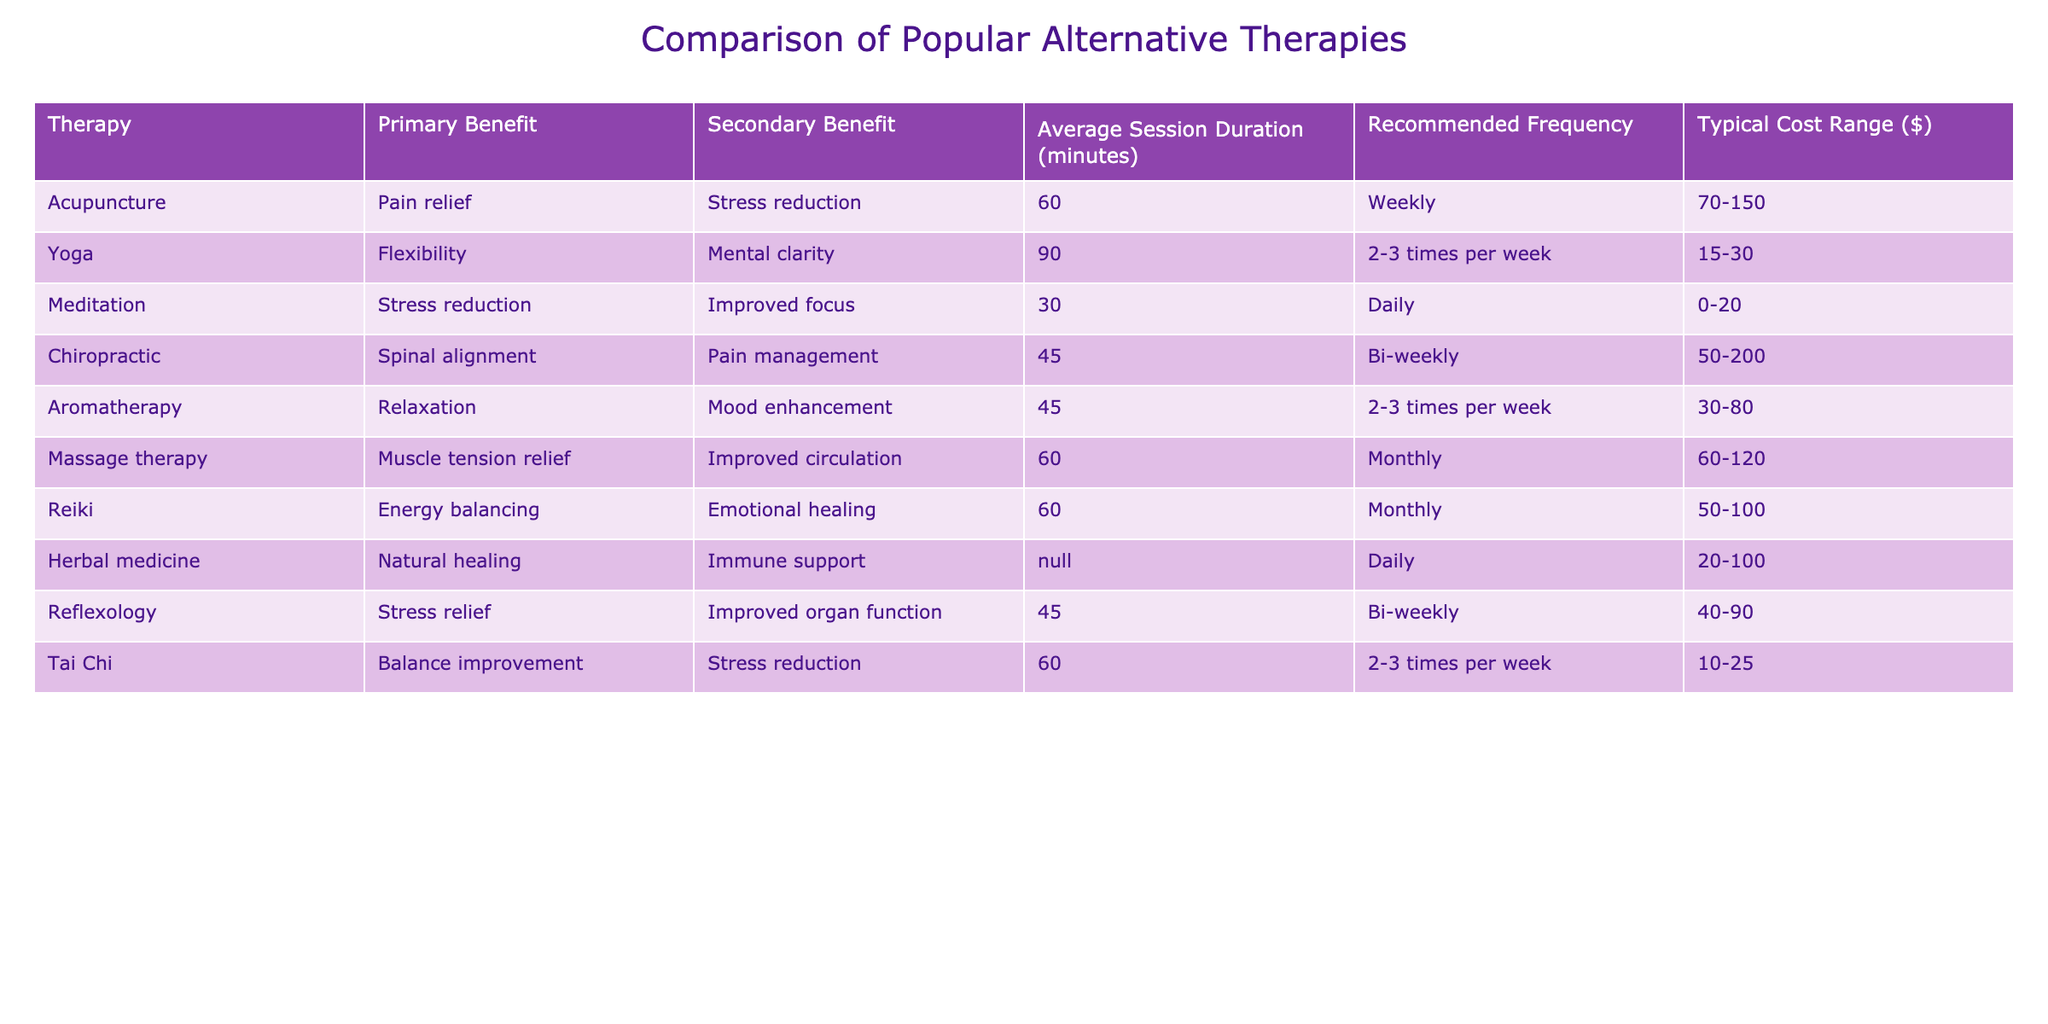What is the primary benefit of Reiki? According to the table, the primary benefit listed for Reiki is energy balancing.
Answer: Energy balancing What is the typical cost range for acupuncture? The table shows that the typical cost range for acupuncture is between $70 and $150.
Answer: $70-150 Which therapy has the longest average session duration? By comparing the average session durations, yoga has the longest duration at 90 minutes.
Answer: Yoga Does meditation have a secondary benefit listed in the table? Yes, the table indicates that meditation offers improved focus as a secondary benefit.
Answer: Yes How often is yoga recommended? The table states that yoga is recommended to be practiced 2-3 times per week.
Answer: 2-3 times per week Which therapy is the least expensive based on the cost range? By examining the cost ranges, Tai Chi is the least expensive, with a range of $10 to $25.
Answer: Tai Chi What is the average session duration for reflexology, and how does it compare to that of massage therapy? Reflexology has an average session duration of 45 minutes, while massage therapy also has the same duration of 60 minutes; therefore, massage therapy is longer.
Answer: Massage therapy is longer If a person practices meditation daily, how many sessions would they have in a month? Since there are 30 days in a month, practicing meditation daily results in 30 sessions in a month.
Answer: 30 sessions Is there a therapy listed that does not have a specified average session duration? Yes, herbal medicine does not have an average session duration specified in the table.
Answer: Yes What is the total cost range for Aromatherapy and Reiki combined? The cost range for Aromatherapy is $30 to $80, and for Reiki, it is $50 to $100. Adding the minimums gives $80 and the maximums give $180, resulting in a combined range of $80-$180.
Answer: $80-180 Which alternative therapy is suggested for stress reduction? The table mentions meditation and Tai Chi as therapies that provide stress reduction as a primary or secondary benefit.
Answer: Meditation and Tai Chi 